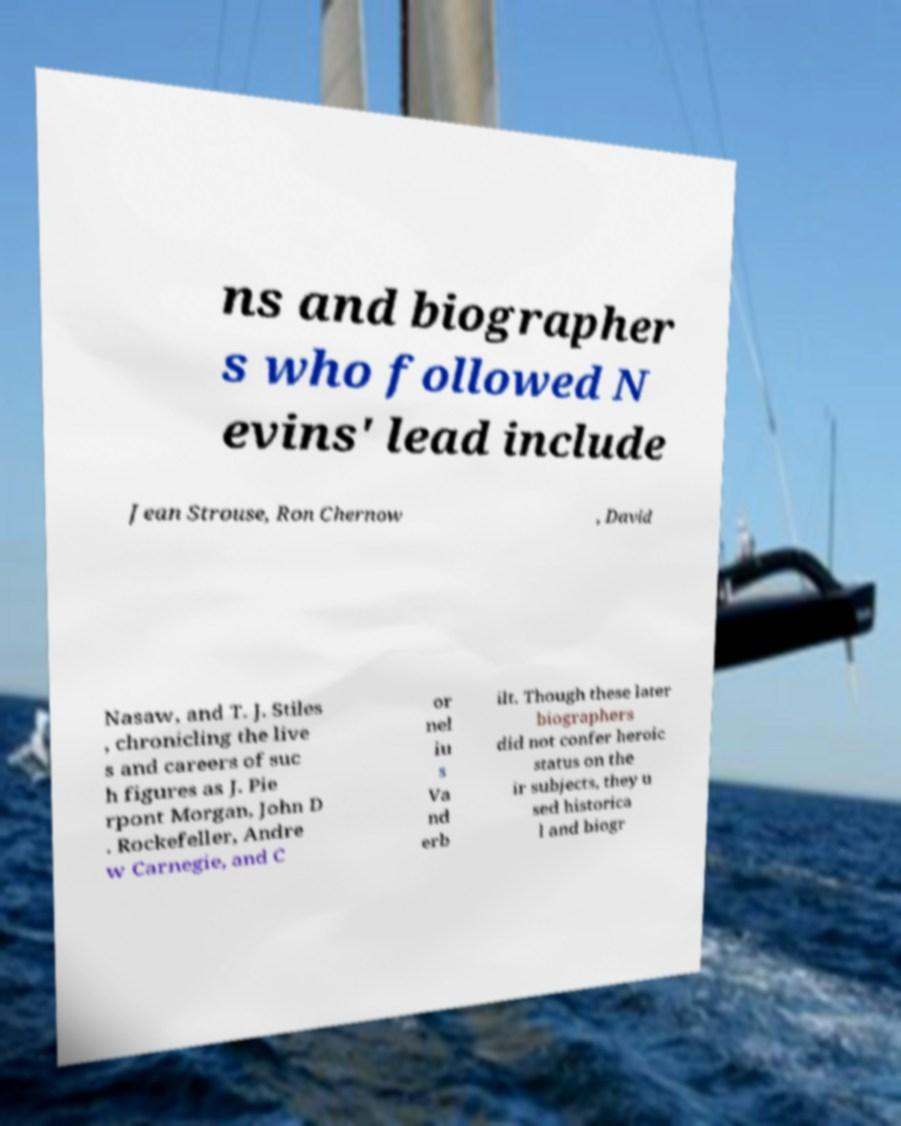Please identify and transcribe the text found in this image. ns and biographer s who followed N evins' lead include Jean Strouse, Ron Chernow , David Nasaw, and T. J. Stiles , chronicling the live s and careers of suc h figures as J. Pie rpont Morgan, John D . Rockefeller, Andre w Carnegie, and C or nel iu s Va nd erb ilt. Though these later biographers did not confer heroic status on the ir subjects, they u sed historica l and biogr 